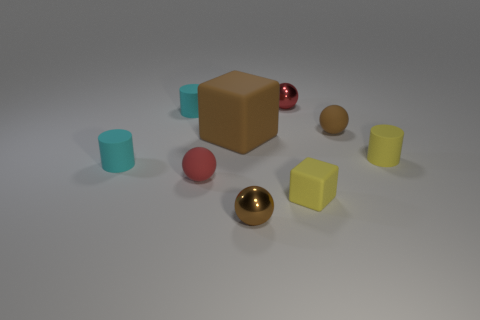Is the shape of the tiny red shiny object the same as the large brown object that is behind the red matte object?
Offer a terse response. No. There is another yellow object that is the same shape as the big rubber object; what is its size?
Give a very brief answer. Small. Does the small matte cube have the same color as the rubber ball that is behind the yellow rubber cylinder?
Provide a short and direct response. No. What number of other objects are there of the same size as the brown matte block?
Your answer should be very brief. 0. What shape is the tiny yellow thing in front of the yellow thing behind the cyan matte thing that is in front of the tiny brown rubber object?
Your answer should be very brief. Cube. There is a red rubber thing; does it have the same size as the brown block that is behind the small yellow matte block?
Provide a succinct answer. No. There is a tiny ball that is both in front of the big brown thing and behind the yellow block; what color is it?
Provide a succinct answer. Red. What number of other things are the same shape as the large brown rubber object?
Offer a terse response. 1. Do the small rubber ball that is behind the yellow rubber cylinder and the matte sphere left of the small yellow matte block have the same color?
Provide a short and direct response. No. There is a rubber cube that is to the right of the red metal thing; does it have the same size as the red thing that is behind the small yellow cylinder?
Provide a short and direct response. Yes. 